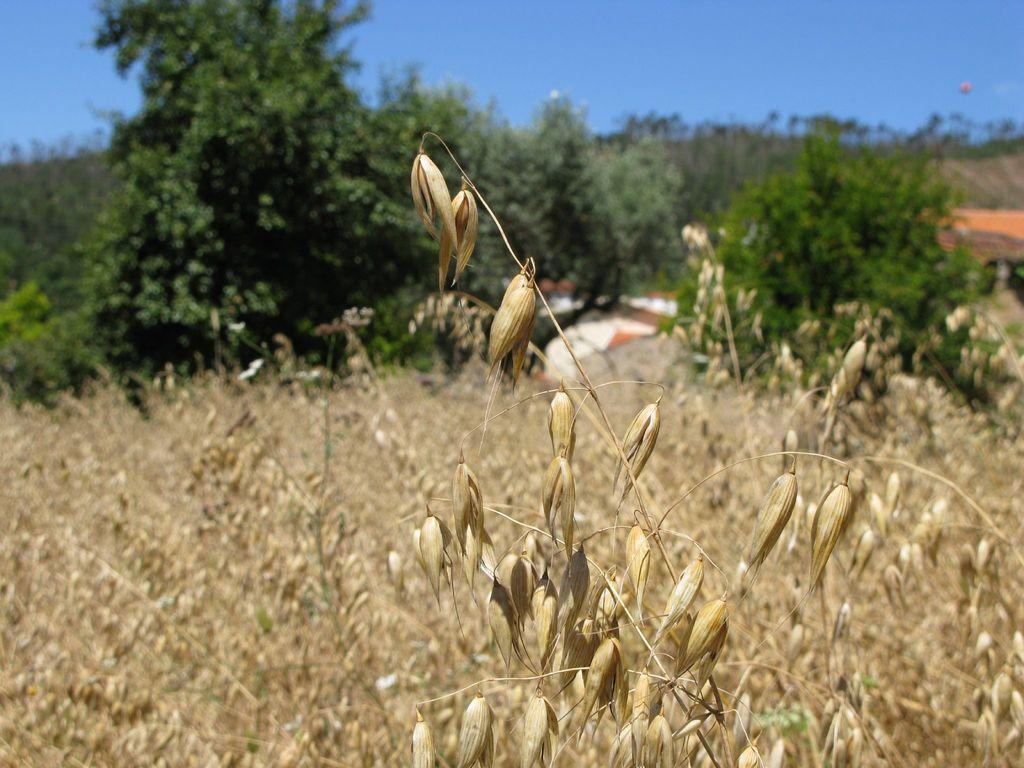What type of vegetation is located at the front of the image? There are plants in the front of the image. What can be seen in the background of the image? There are trees, buildings, and the sky visible in the background of the image. What type of mine is depicted in the image? There is no mine present in the image. How does the ticket affect the cause of the event in the image? There is no ticket or event present in the image. 